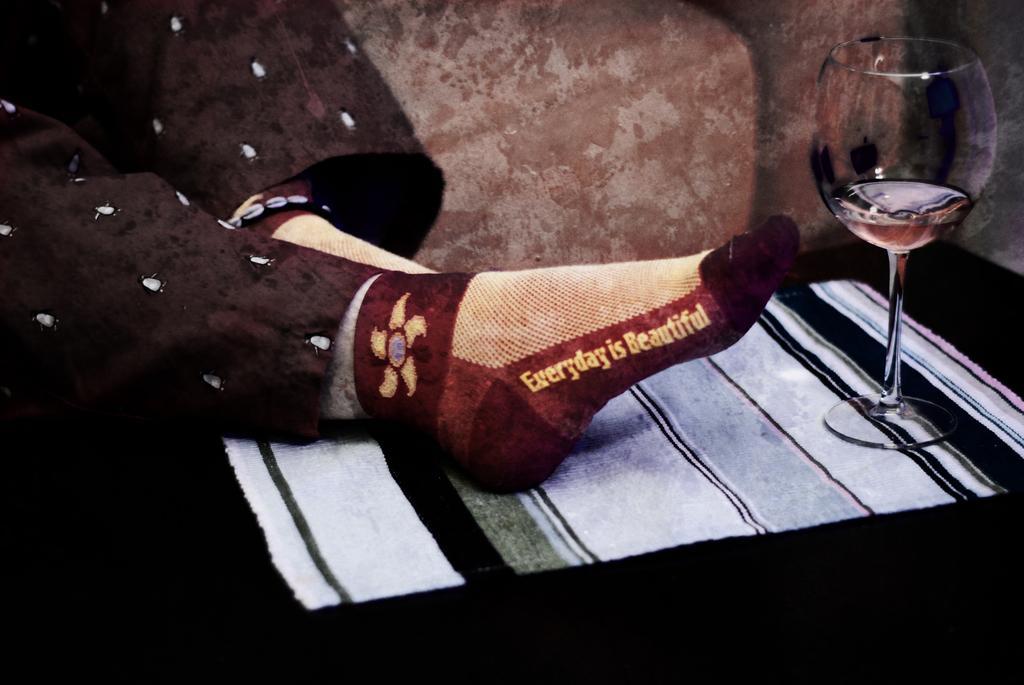In one or two sentences, can you explain what this image depicts? This image is taken indoors. At the bottom of the image there is a table with a napkin and a glass of wine on it. In the background there is a couch and a person is sitting on the couch and placing the legs on the table. 